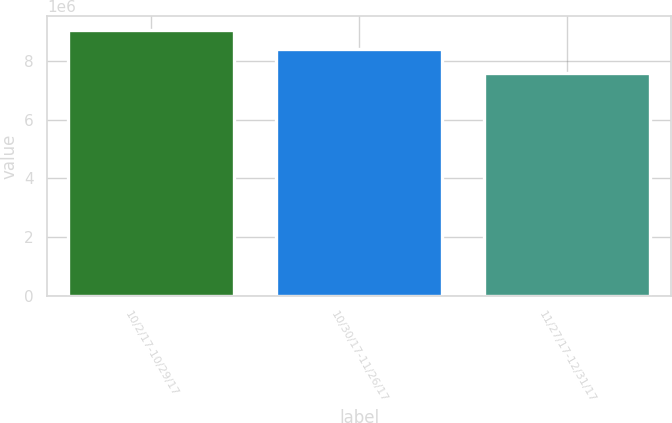Convert chart to OTSL. <chart><loc_0><loc_0><loc_500><loc_500><bar_chart><fcel>10/2/17-10/29/17<fcel>10/30/17-11/26/17<fcel>11/27/17-12/31/17<nl><fcel>9.0587e+06<fcel>8.38886e+06<fcel>7.58541e+06<nl></chart> 